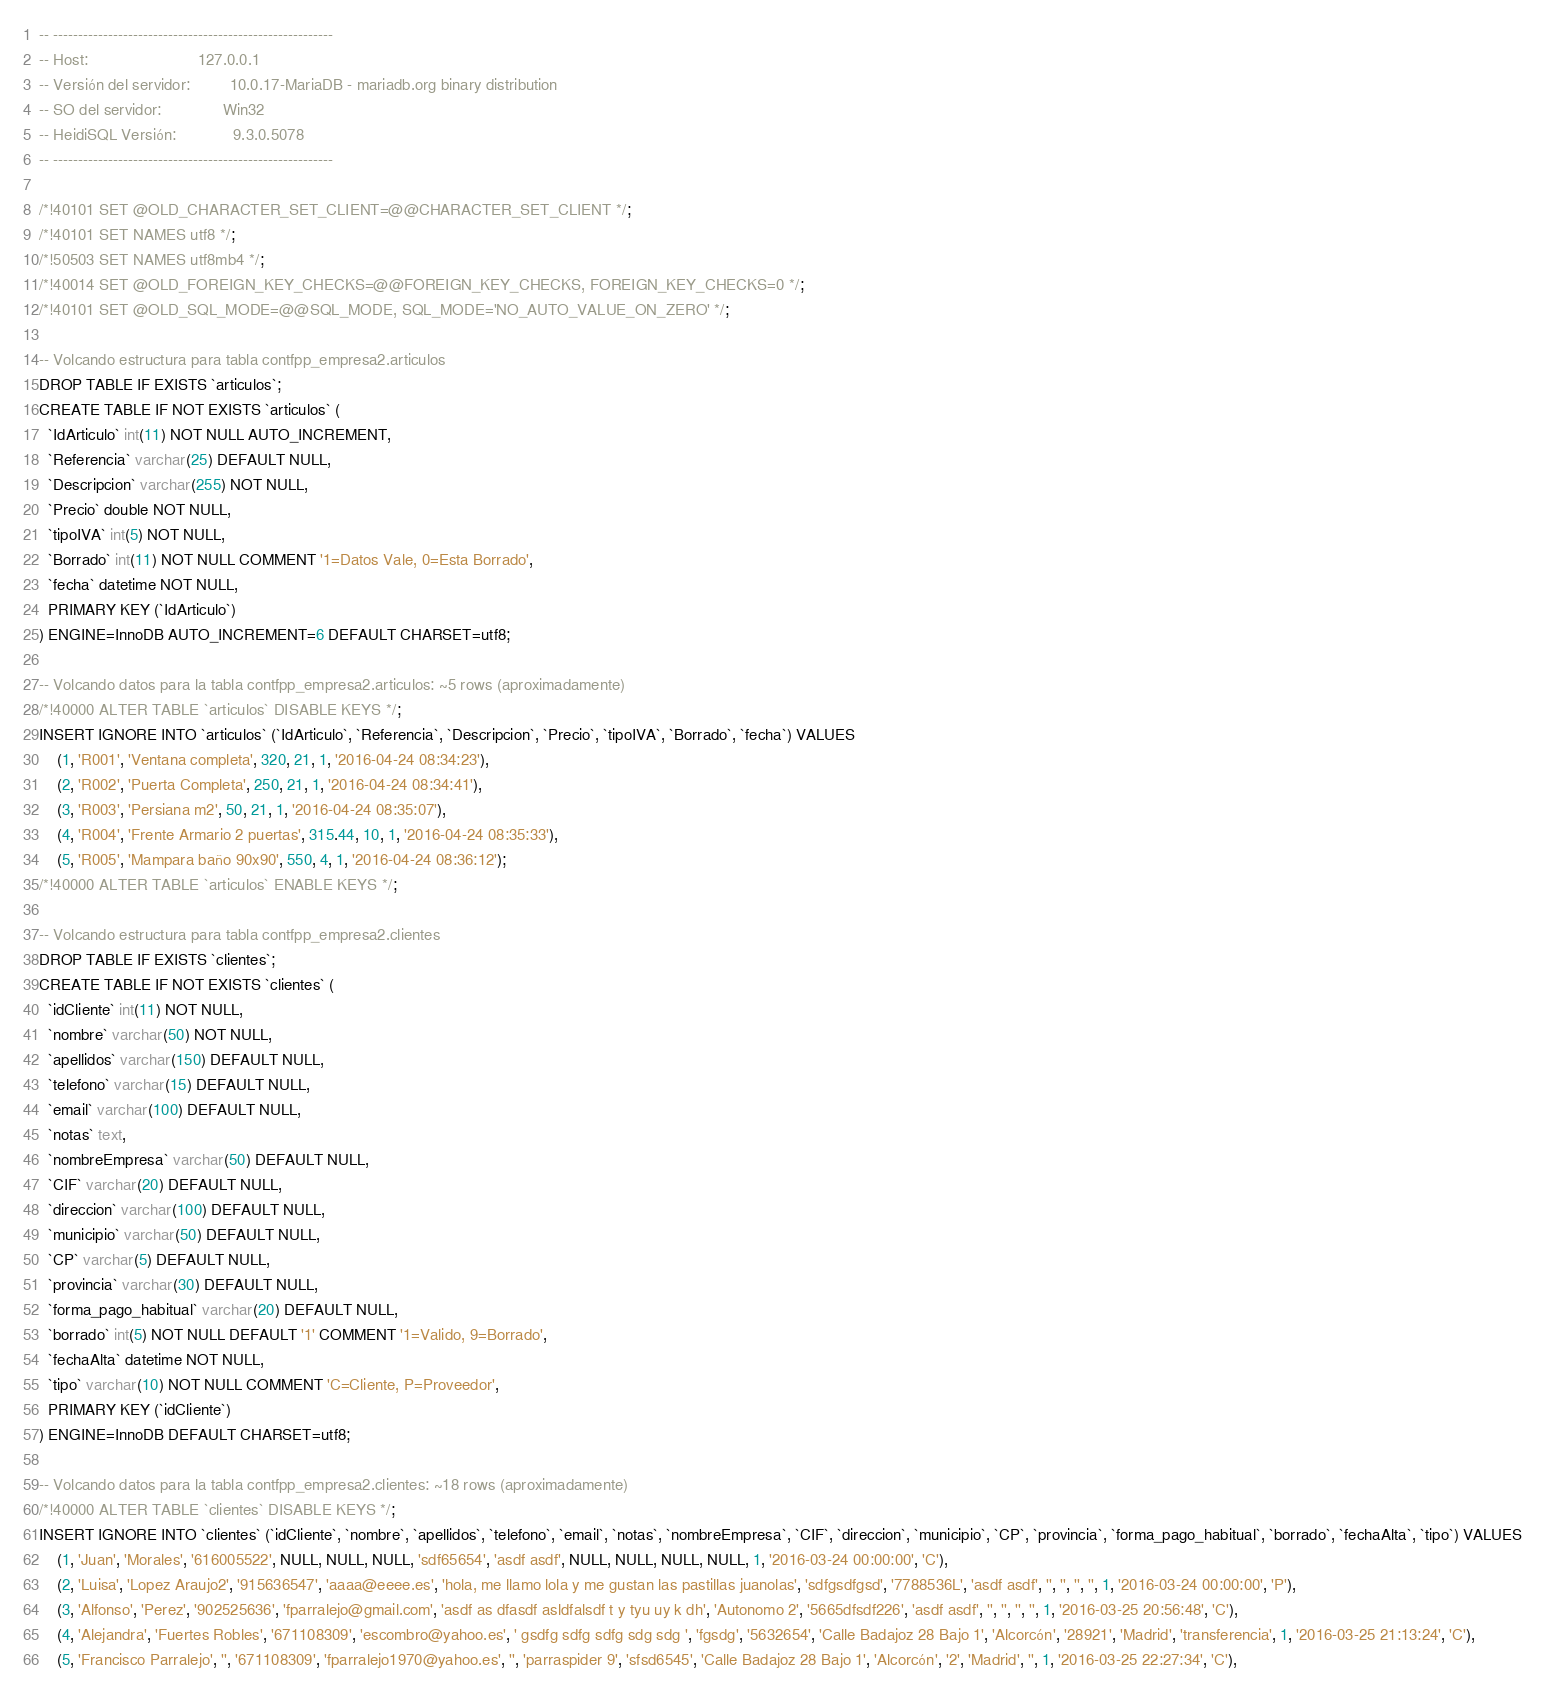<code> <loc_0><loc_0><loc_500><loc_500><_SQL_>-- --------------------------------------------------------
-- Host:                         127.0.0.1
-- Versión del servidor:         10.0.17-MariaDB - mariadb.org binary distribution
-- SO del servidor:              Win32
-- HeidiSQL Versión:             9.3.0.5078
-- --------------------------------------------------------

/*!40101 SET @OLD_CHARACTER_SET_CLIENT=@@CHARACTER_SET_CLIENT */;
/*!40101 SET NAMES utf8 */;
/*!50503 SET NAMES utf8mb4 */;
/*!40014 SET @OLD_FOREIGN_KEY_CHECKS=@@FOREIGN_KEY_CHECKS, FOREIGN_KEY_CHECKS=0 */;
/*!40101 SET @OLD_SQL_MODE=@@SQL_MODE, SQL_MODE='NO_AUTO_VALUE_ON_ZERO' */;

-- Volcando estructura para tabla contfpp_empresa2.articulos
DROP TABLE IF EXISTS `articulos`;
CREATE TABLE IF NOT EXISTS `articulos` (
  `IdArticulo` int(11) NOT NULL AUTO_INCREMENT,
  `Referencia` varchar(25) DEFAULT NULL,
  `Descripcion` varchar(255) NOT NULL,
  `Precio` double NOT NULL,
  `tipoIVA` int(5) NOT NULL,
  `Borrado` int(11) NOT NULL COMMENT '1=Datos Vale, 0=Esta Borrado',
  `fecha` datetime NOT NULL,
  PRIMARY KEY (`IdArticulo`)
) ENGINE=InnoDB AUTO_INCREMENT=6 DEFAULT CHARSET=utf8;

-- Volcando datos para la tabla contfpp_empresa2.articulos: ~5 rows (aproximadamente)
/*!40000 ALTER TABLE `articulos` DISABLE KEYS */;
INSERT IGNORE INTO `articulos` (`IdArticulo`, `Referencia`, `Descripcion`, `Precio`, `tipoIVA`, `Borrado`, `fecha`) VALUES
	(1, 'R001', 'Ventana completa', 320, 21, 1, '2016-04-24 08:34:23'),
	(2, 'R002', 'Puerta Completa', 250, 21, 1, '2016-04-24 08:34:41'),
	(3, 'R003', 'Persiana m2', 50, 21, 1, '2016-04-24 08:35:07'),
	(4, 'R004', 'Frente Armario 2 puertas', 315.44, 10, 1, '2016-04-24 08:35:33'),
	(5, 'R005', 'Mampara baño 90x90', 550, 4, 1, '2016-04-24 08:36:12');
/*!40000 ALTER TABLE `articulos` ENABLE KEYS */;

-- Volcando estructura para tabla contfpp_empresa2.clientes
DROP TABLE IF EXISTS `clientes`;
CREATE TABLE IF NOT EXISTS `clientes` (
  `idCliente` int(11) NOT NULL,
  `nombre` varchar(50) NOT NULL,
  `apellidos` varchar(150) DEFAULT NULL,
  `telefono` varchar(15) DEFAULT NULL,
  `email` varchar(100) DEFAULT NULL,
  `notas` text,
  `nombreEmpresa` varchar(50) DEFAULT NULL,
  `CIF` varchar(20) DEFAULT NULL,
  `direccion` varchar(100) DEFAULT NULL,
  `municipio` varchar(50) DEFAULT NULL,
  `CP` varchar(5) DEFAULT NULL,
  `provincia` varchar(30) DEFAULT NULL,
  `forma_pago_habitual` varchar(20) DEFAULT NULL,
  `borrado` int(5) NOT NULL DEFAULT '1' COMMENT '1=Valido, 9=Borrado',
  `fechaAlta` datetime NOT NULL,
  `tipo` varchar(10) NOT NULL COMMENT 'C=Cliente, P=Proveedor',
  PRIMARY KEY (`idCliente`)
) ENGINE=InnoDB DEFAULT CHARSET=utf8;

-- Volcando datos para la tabla contfpp_empresa2.clientes: ~18 rows (aproximadamente)
/*!40000 ALTER TABLE `clientes` DISABLE KEYS */;
INSERT IGNORE INTO `clientes` (`idCliente`, `nombre`, `apellidos`, `telefono`, `email`, `notas`, `nombreEmpresa`, `CIF`, `direccion`, `municipio`, `CP`, `provincia`, `forma_pago_habitual`, `borrado`, `fechaAlta`, `tipo`) VALUES
	(1, 'Juan', 'Morales', '616005522', NULL, NULL, NULL, 'sdf65654', 'asdf asdf', NULL, NULL, NULL, NULL, 1, '2016-03-24 00:00:00', 'C'),
	(2, 'Luisa', 'Lopez Araujo2', '915636547', 'aaaa@eeee.es', 'hola, me llamo lola y me gustan las pastillas juanolas', 'sdfgsdfgsd', '7788536L', 'asdf asdf', '', '', '', '', 1, '2016-03-24 00:00:00', 'P'),
	(3, 'Alfonso', 'Perez', '902525636', 'fparralejo@gmail.com', 'asdf as dfasdf asldfalsdf t y tyu uy k dh', 'Autonomo 2', '5665dfsdf226', 'asdf asdf', '', '', '', '', 1, '2016-03-25 20:56:48', 'C'),
	(4, 'Alejandra', 'Fuertes Robles', '671108309', 'escombro@yahoo.es', ' gsdfg sdfg sdfg sdg sdg ', 'fgsdg', '5632654', 'Calle Badajoz 28 Bajo 1', 'Alcorcón', '28921', 'Madrid', 'transferencia', 1, '2016-03-25 21:13:24', 'C'),
	(5, 'Francisco Parralejo', '', '671108309', 'fparralejo1970@yahoo.es', '', 'parraspider 9', 'sfsd6545', 'Calle Badajoz 28 Bajo 1', 'Alcorcón', '2', 'Madrid', '', 1, '2016-03-25 22:27:34', 'C'),</code> 